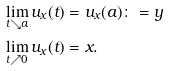<formula> <loc_0><loc_0><loc_500><loc_500>\lim _ { t \searrow a } { u _ { x } ( t ) } & = u _ { x } ( a ) \colon = y \\ \lim _ { t \nearrow 0 } { u _ { x } ( t ) } & = x .</formula> 